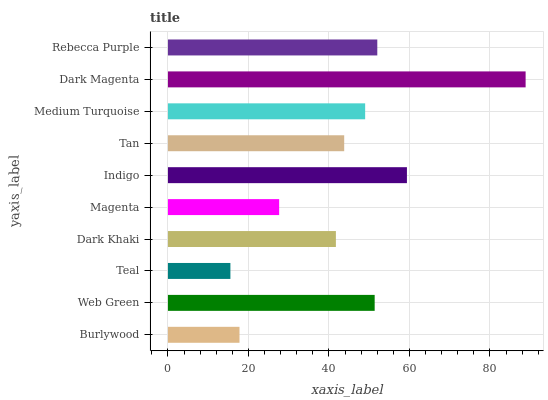Is Teal the minimum?
Answer yes or no. Yes. Is Dark Magenta the maximum?
Answer yes or no. Yes. Is Web Green the minimum?
Answer yes or no. No. Is Web Green the maximum?
Answer yes or no. No. Is Web Green greater than Burlywood?
Answer yes or no. Yes. Is Burlywood less than Web Green?
Answer yes or no. Yes. Is Burlywood greater than Web Green?
Answer yes or no. No. Is Web Green less than Burlywood?
Answer yes or no. No. Is Medium Turquoise the high median?
Answer yes or no. Yes. Is Tan the low median?
Answer yes or no. Yes. Is Burlywood the high median?
Answer yes or no. No. Is Teal the low median?
Answer yes or no. No. 